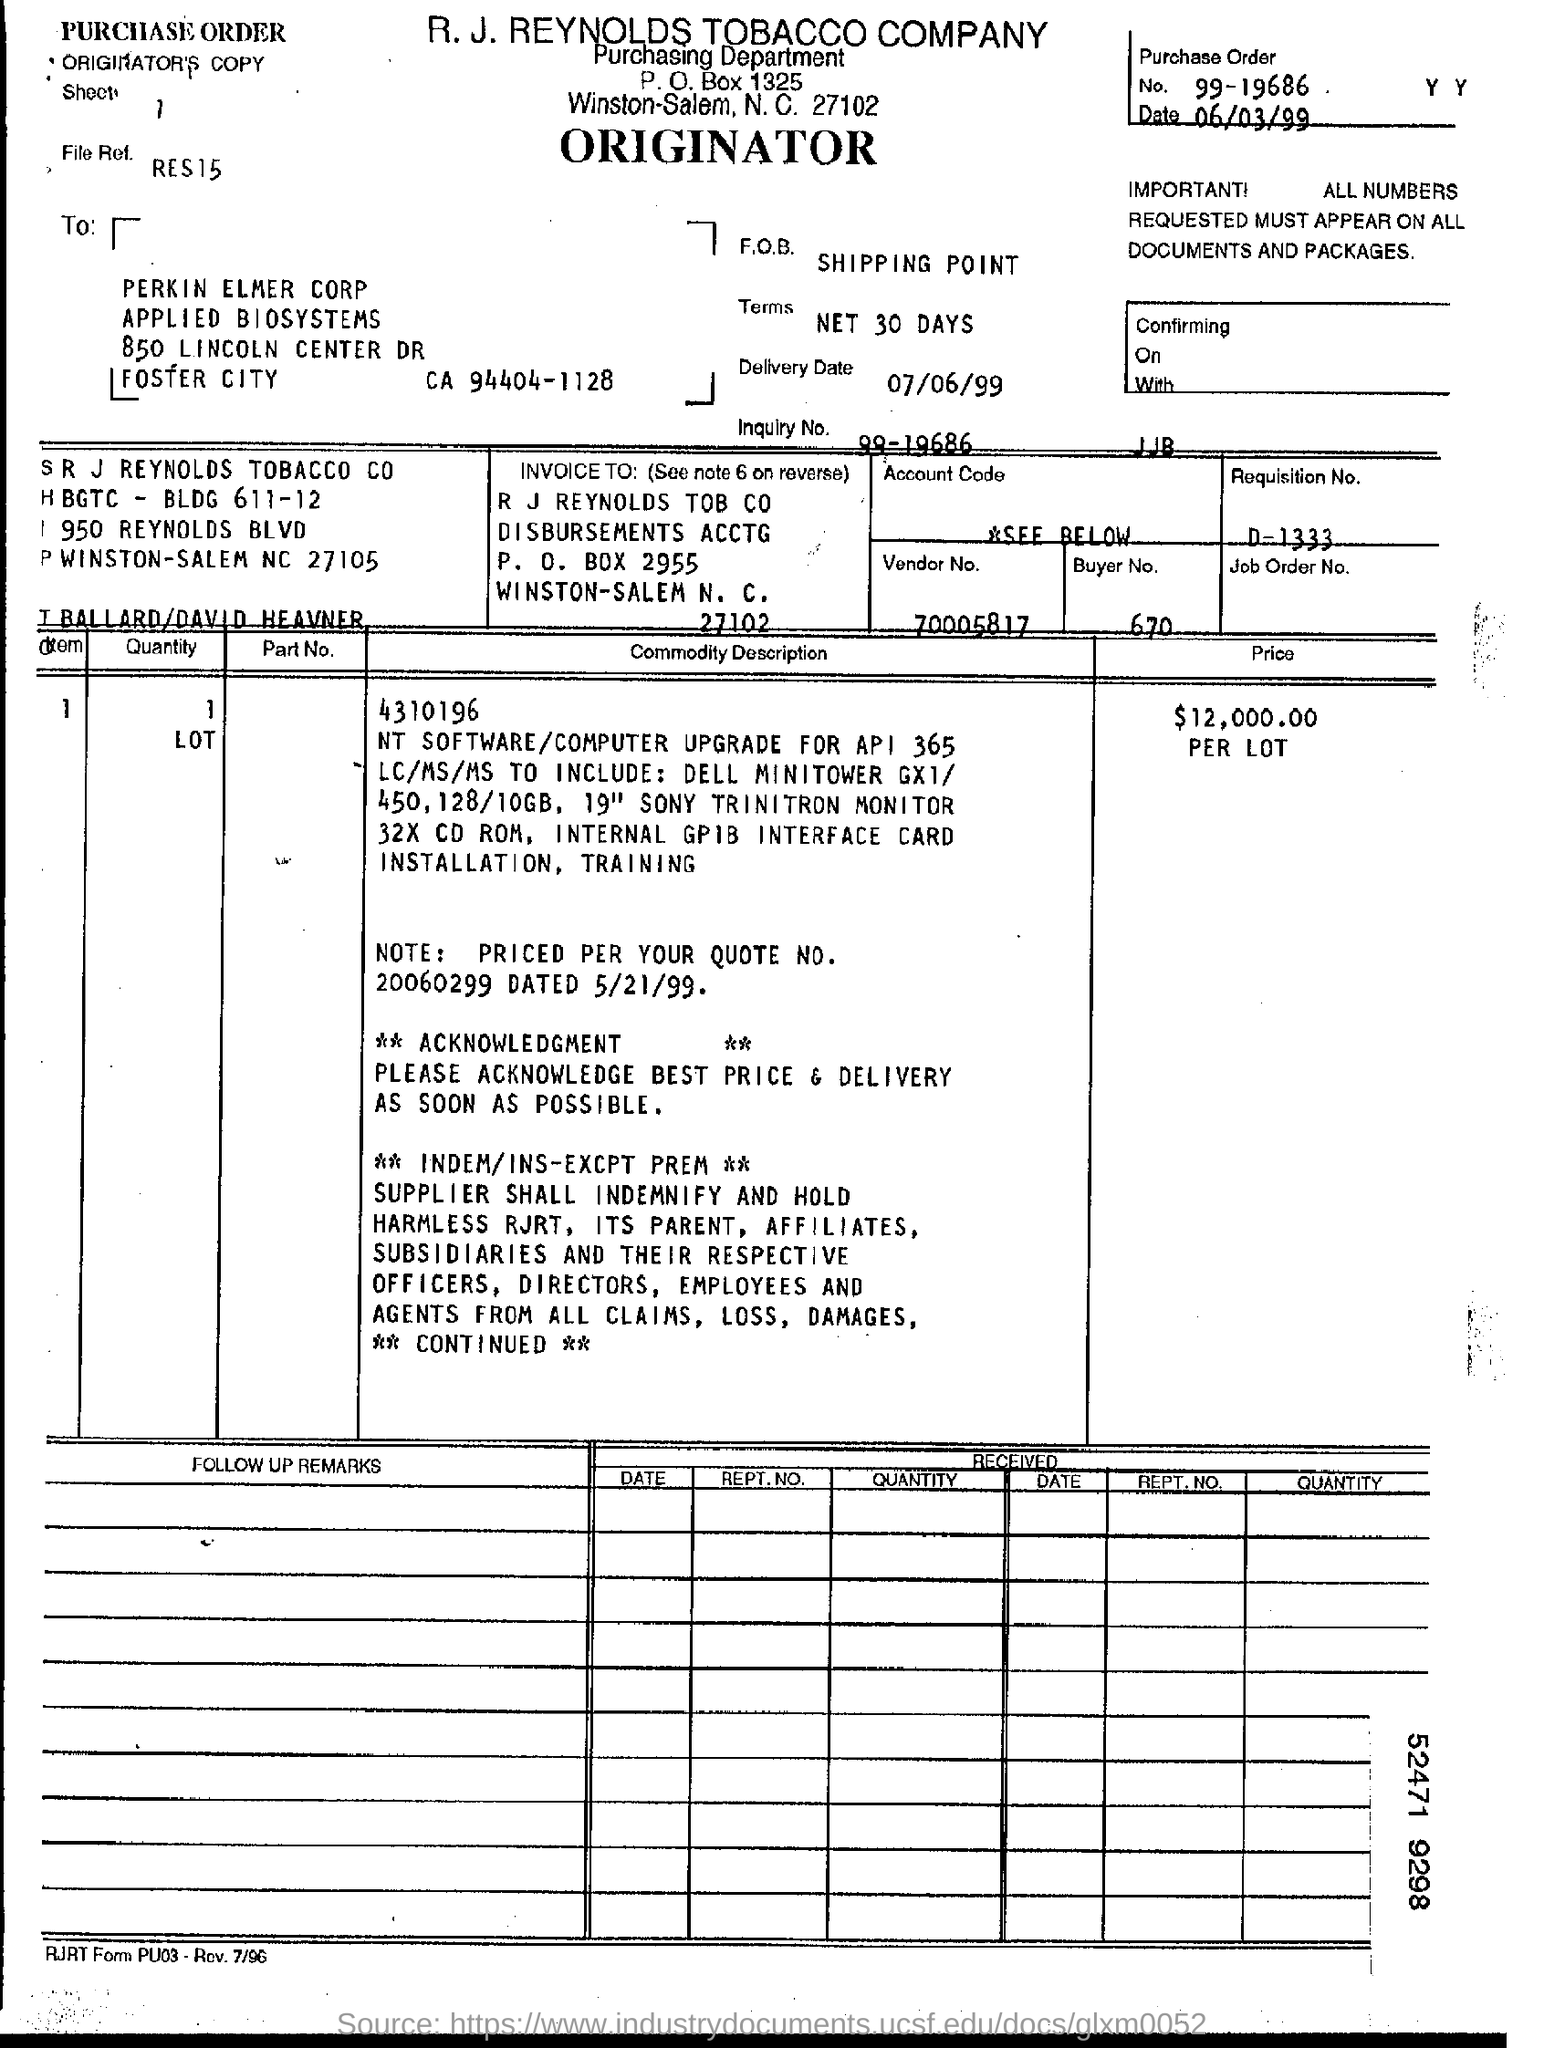Highlight a few significant elements in this photo. The vendor number is 70005817. I have just received a message inquiring about the buyer number, specifically asking 'what is the buyer number? 670...'. The number of purchase order is 99-19686. 